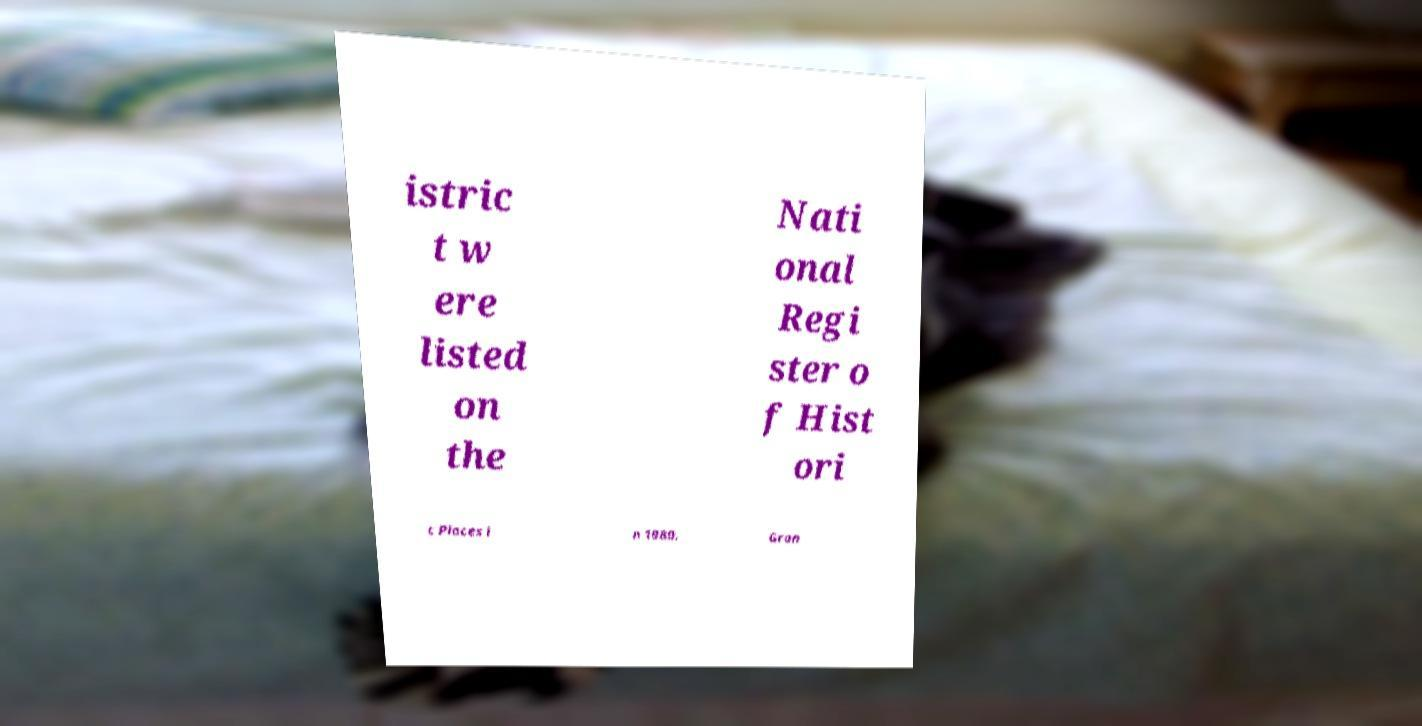Please identify and transcribe the text found in this image. istric t w ere listed on the Nati onal Regi ster o f Hist ori c Places i n 1980. Gran 